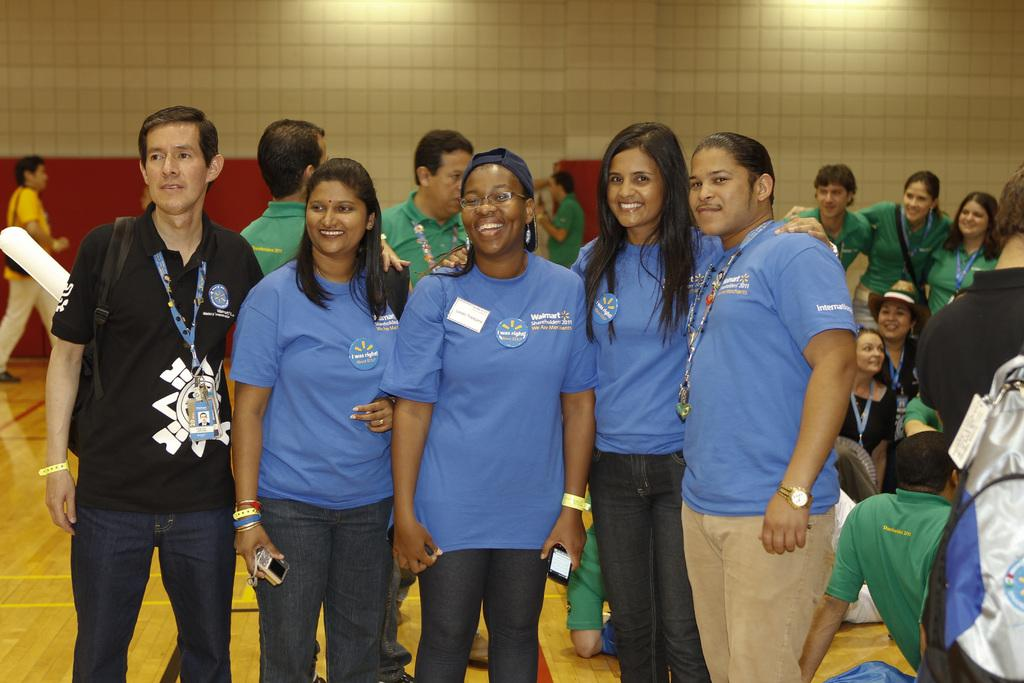What is happening with the group of people in the image? The people in the image are standing and smiling. Can you describe the people in the background of the image? There are people visible in the background of the image. What is at the bottom portion of the image? There is a floor at the bottom portion of the image. What type of bead is being used to make an agreement between the people in the image? There is no bead or agreement-making process depicted in the image. Can you tell me the age of the grandfather in the image? There is no grandfather present in the image. 